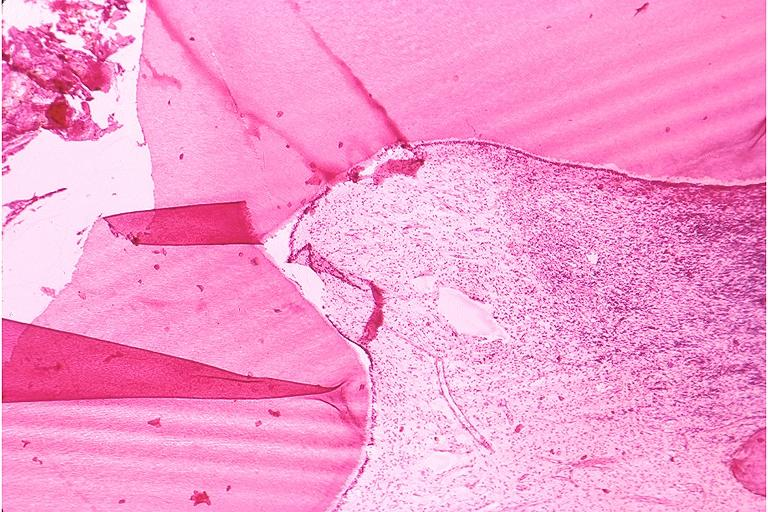s cervix duplication present?
Answer the question using a single word or phrase. No 